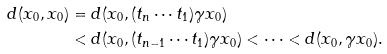<formula> <loc_0><loc_0><loc_500><loc_500>d ( x _ { 0 } , x _ { 0 } ) & = d ( x _ { 0 } , ( t _ { n } \cdots t _ { 1 } ) \gamma x _ { 0 } ) \\ & < d ( x _ { 0 } , ( t _ { n - 1 } \cdots t _ { 1 } ) \gamma x _ { 0 } ) < \dots < d ( x _ { 0 } , \gamma x _ { 0 } ) .</formula> 